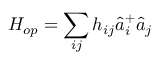Convert formula to latex. <formula><loc_0><loc_0><loc_500><loc_500>H _ { o p } = \sum _ { i j } h _ { i j } \hat { a } _ { i } ^ { + } \hat { a } _ { j }</formula> 